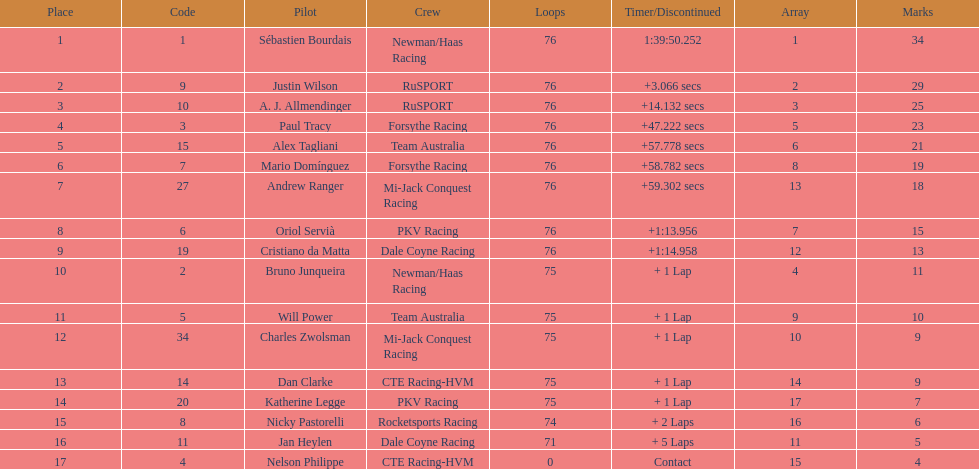Parse the full table. {'header': ['Place', 'Code', 'Pilot', 'Crew', 'Loops', 'Timer/Discontinued', 'Array', 'Marks'], 'rows': [['1', '1', 'Sébastien Bourdais', 'Newman/Haas Racing', '76', '1:39:50.252', '1', '34'], ['2', '9', 'Justin Wilson', 'RuSPORT', '76', '+3.066 secs', '2', '29'], ['3', '10', 'A. J. Allmendinger', 'RuSPORT', '76', '+14.132 secs', '3', '25'], ['4', '3', 'Paul Tracy', 'Forsythe Racing', '76', '+47.222 secs', '5', '23'], ['5', '15', 'Alex Tagliani', 'Team Australia', '76', '+57.778 secs', '6', '21'], ['6', '7', 'Mario Domínguez', 'Forsythe Racing', '76', '+58.782 secs', '8', '19'], ['7', '27', 'Andrew Ranger', 'Mi-Jack Conquest Racing', '76', '+59.302 secs', '13', '18'], ['8', '6', 'Oriol Servià', 'PKV Racing', '76', '+1:13.956', '7', '15'], ['9', '19', 'Cristiano da Matta', 'Dale Coyne Racing', '76', '+1:14.958', '12', '13'], ['10', '2', 'Bruno Junqueira', 'Newman/Haas Racing', '75', '+ 1 Lap', '4', '11'], ['11', '5', 'Will Power', 'Team Australia', '75', '+ 1 Lap', '9', '10'], ['12', '34', 'Charles Zwolsman', 'Mi-Jack Conquest Racing', '75', '+ 1 Lap', '10', '9'], ['13', '14', 'Dan Clarke', 'CTE Racing-HVM', '75', '+ 1 Lap', '14', '9'], ['14', '20', 'Katherine Legge', 'PKV Racing', '75', '+ 1 Lap', '17', '7'], ['15', '8', 'Nicky Pastorelli', 'Rocketsports Racing', '74', '+ 2 Laps', '16', '6'], ['16', '11', 'Jan Heylen', 'Dale Coyne Racing', '71', '+ 5 Laps', '11', '5'], ['17', '4', 'Nelson Philippe', 'CTE Racing-HVM', '0', 'Contact', '15', '4']]} Which driver earned the least amount of points. Nelson Philippe. 